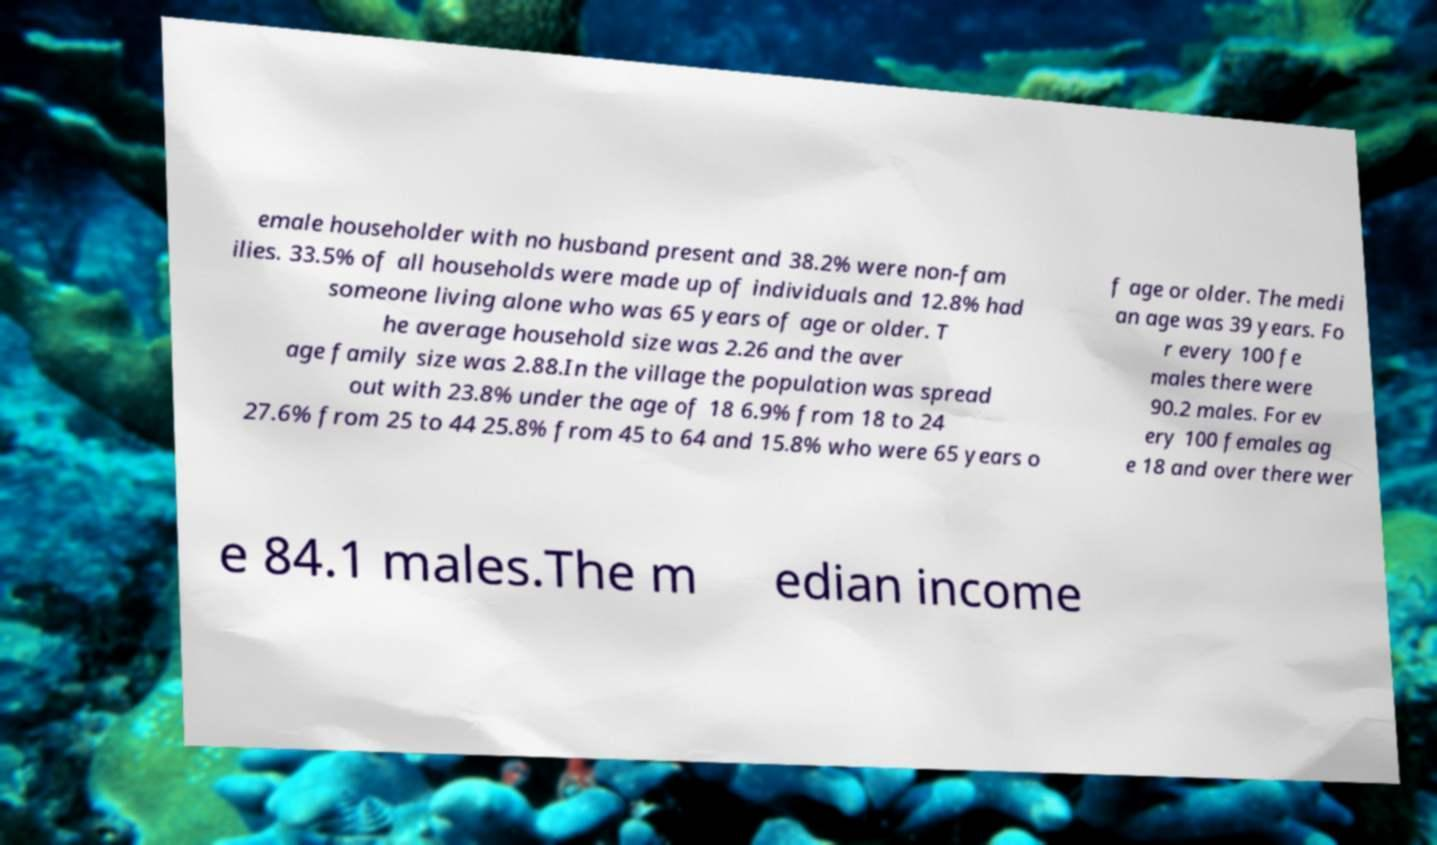Please read and relay the text visible in this image. What does it say? emale householder with no husband present and 38.2% were non-fam ilies. 33.5% of all households were made up of individuals and 12.8% had someone living alone who was 65 years of age or older. T he average household size was 2.26 and the aver age family size was 2.88.In the village the population was spread out with 23.8% under the age of 18 6.9% from 18 to 24 27.6% from 25 to 44 25.8% from 45 to 64 and 15.8% who were 65 years o f age or older. The medi an age was 39 years. Fo r every 100 fe males there were 90.2 males. For ev ery 100 females ag e 18 and over there wer e 84.1 males.The m edian income 